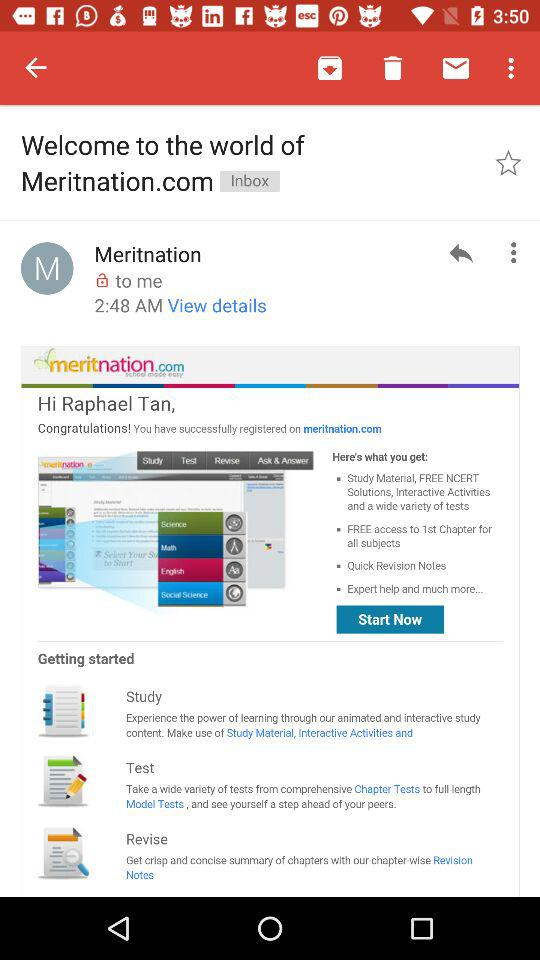When was the mail received? The mail was received at 2:48 AM. 